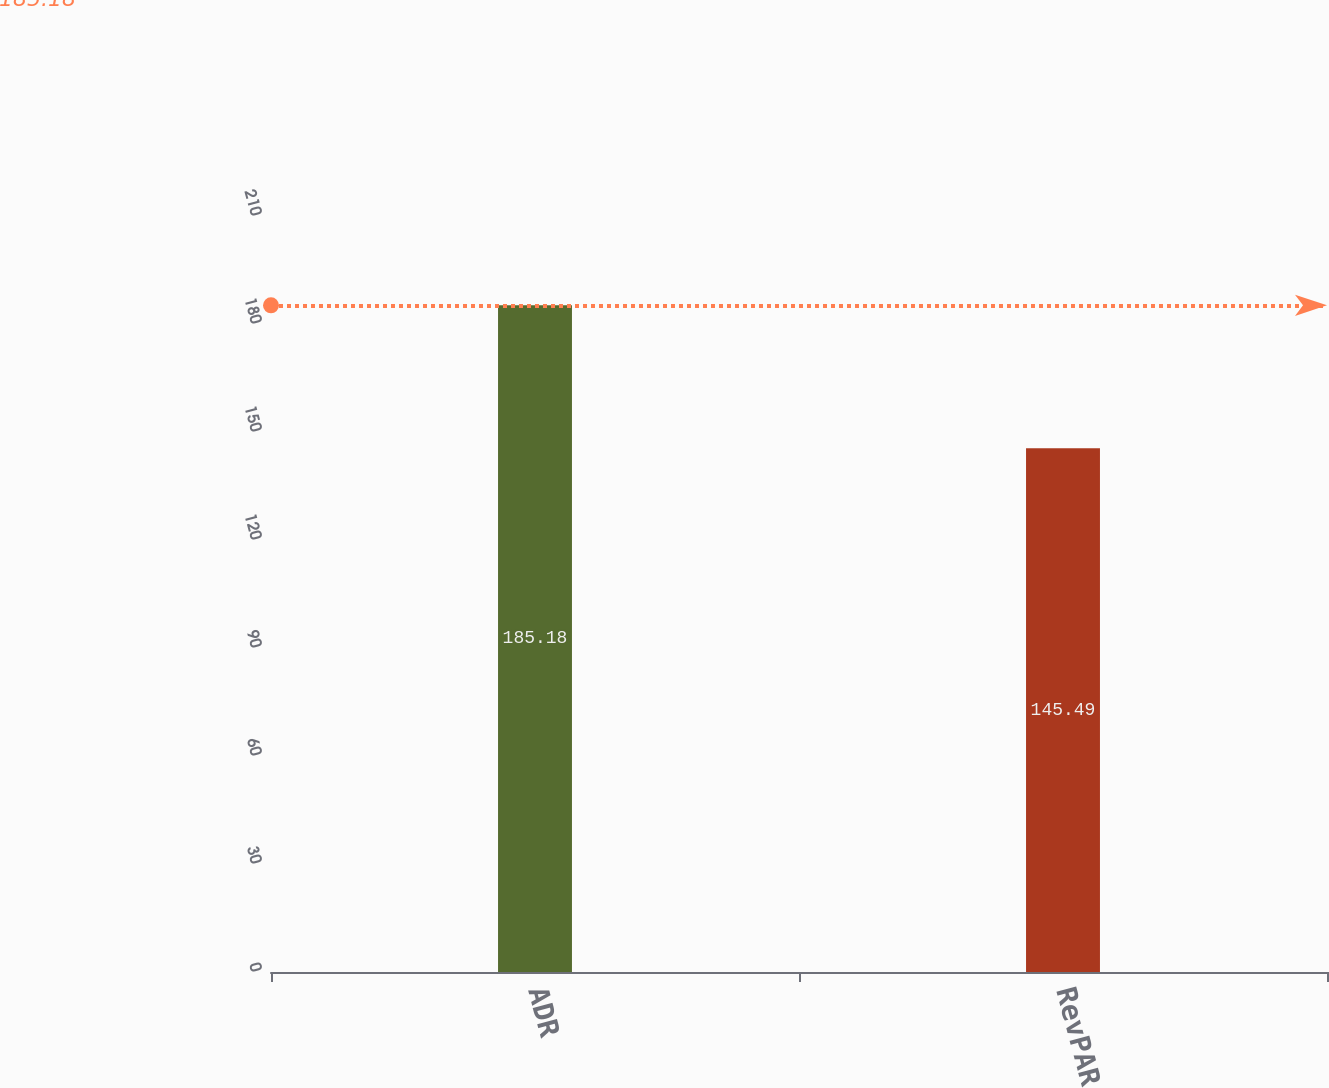Convert chart. <chart><loc_0><loc_0><loc_500><loc_500><bar_chart><fcel>ADR<fcel>RevPAR<nl><fcel>185.18<fcel>145.49<nl></chart> 